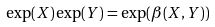Convert formula to latex. <formula><loc_0><loc_0><loc_500><loc_500>\exp ( X ) \exp ( Y ) = \exp ( \beta ( X , Y ) )</formula> 